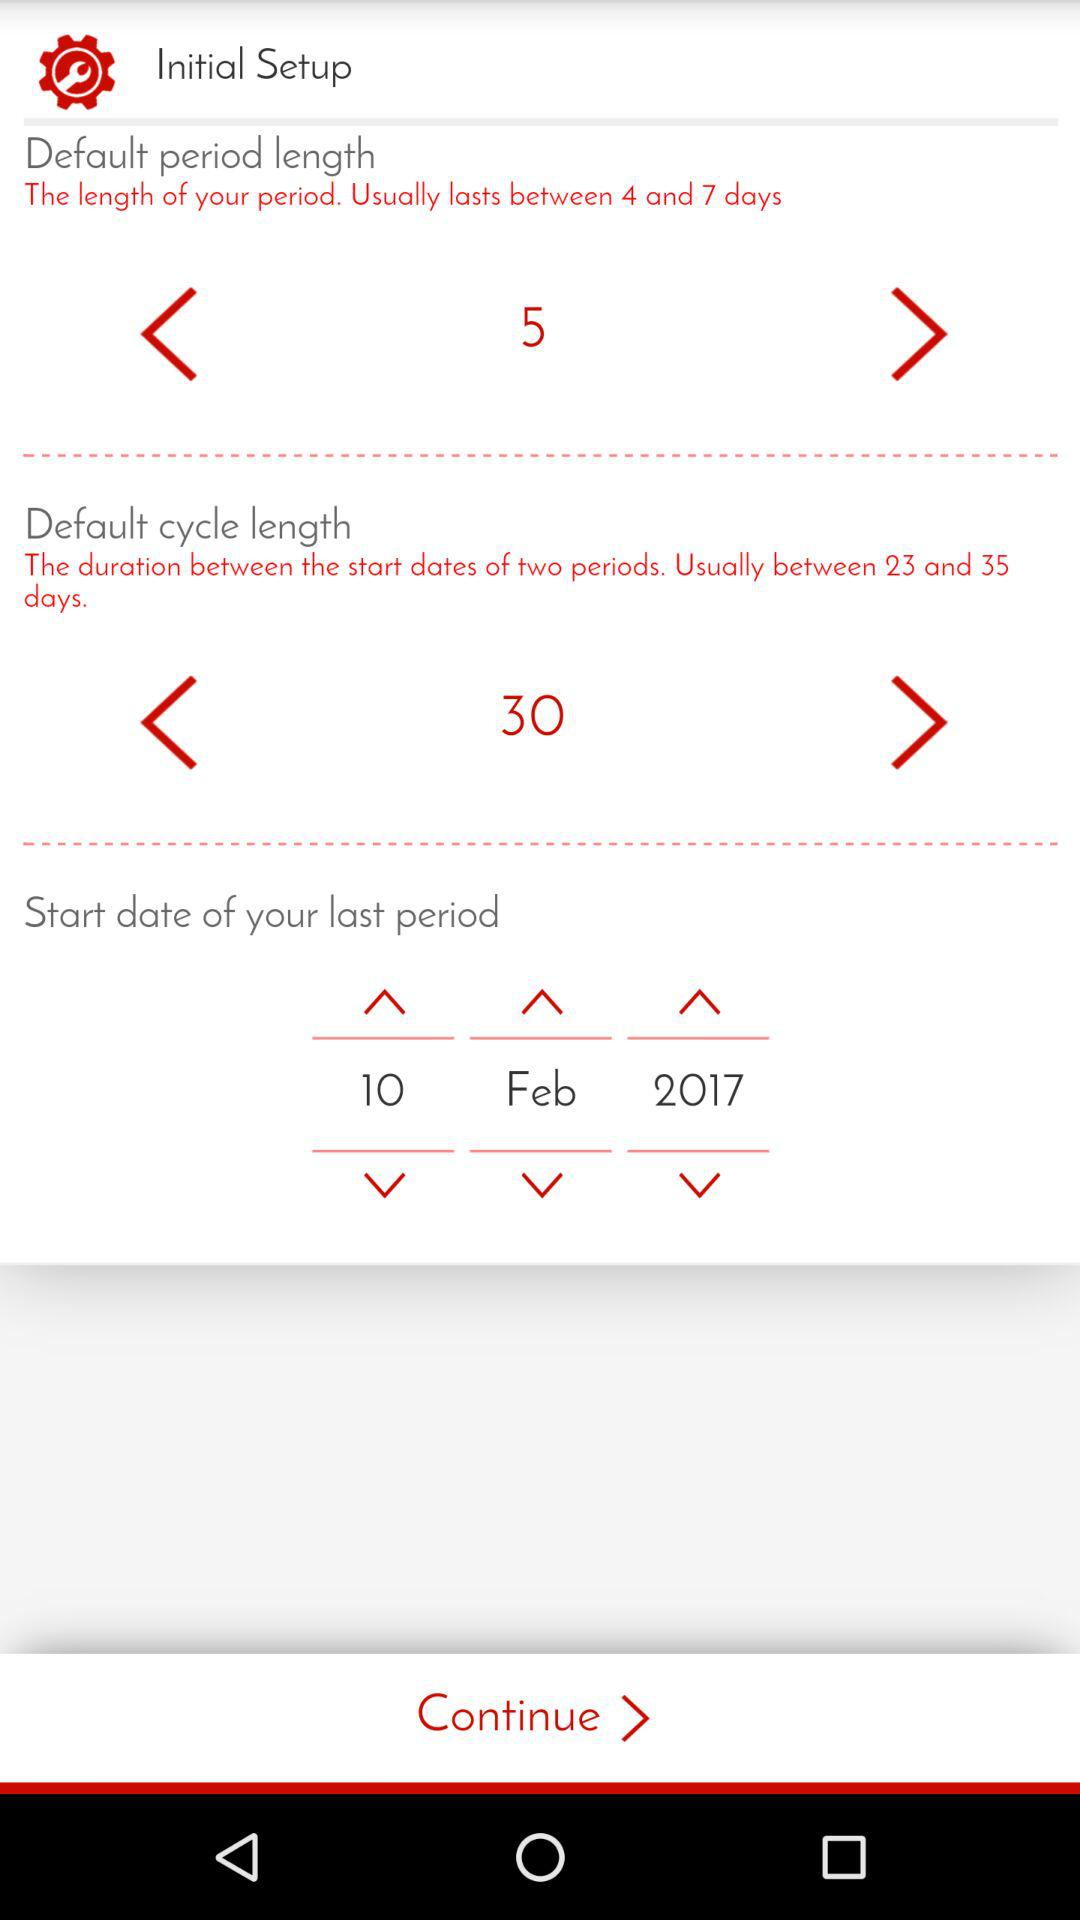What is the default period length? The default period length is 5 days. 